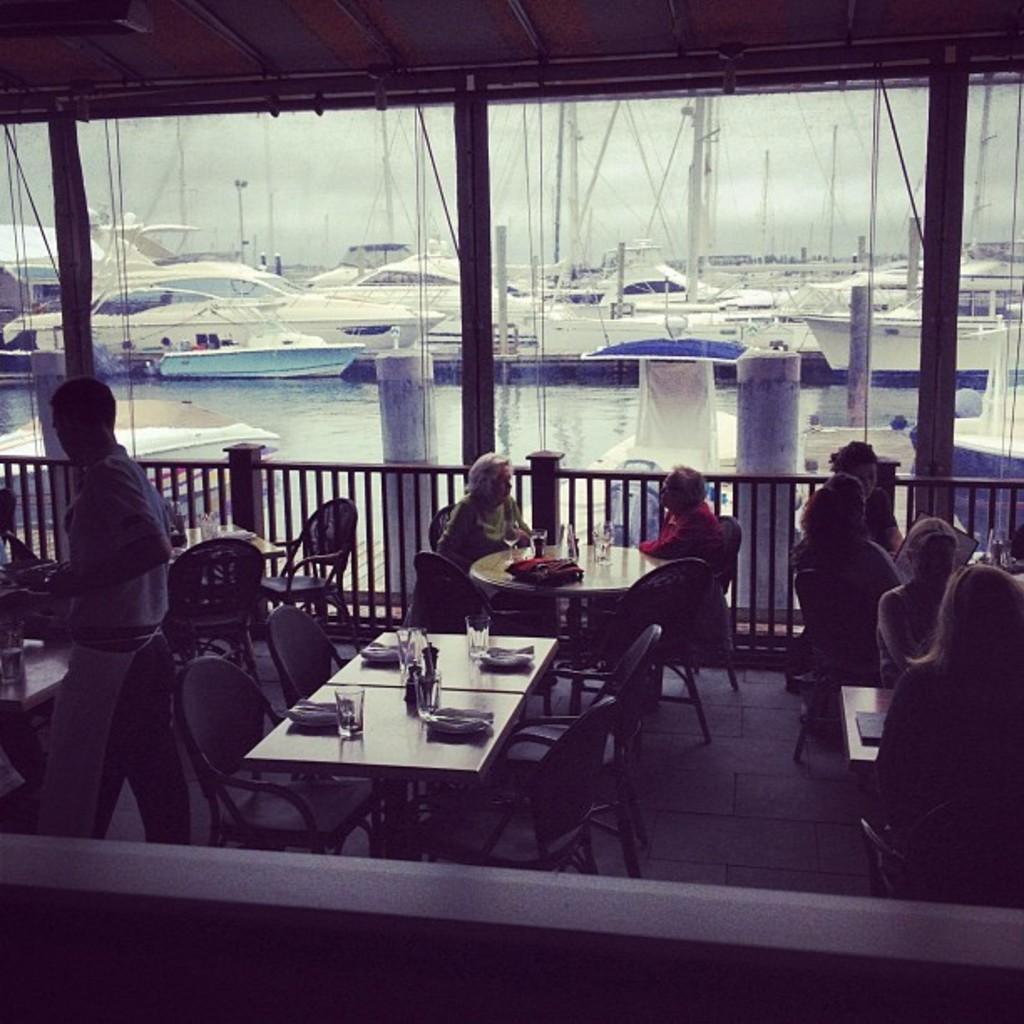How would you summarize this image in a sentence or two? Here we can see a group of people are sitting on the chair and in front here is the table and some objects on it, and here is the fencing, and at back here is the water and ships, and at above here is the sky. 